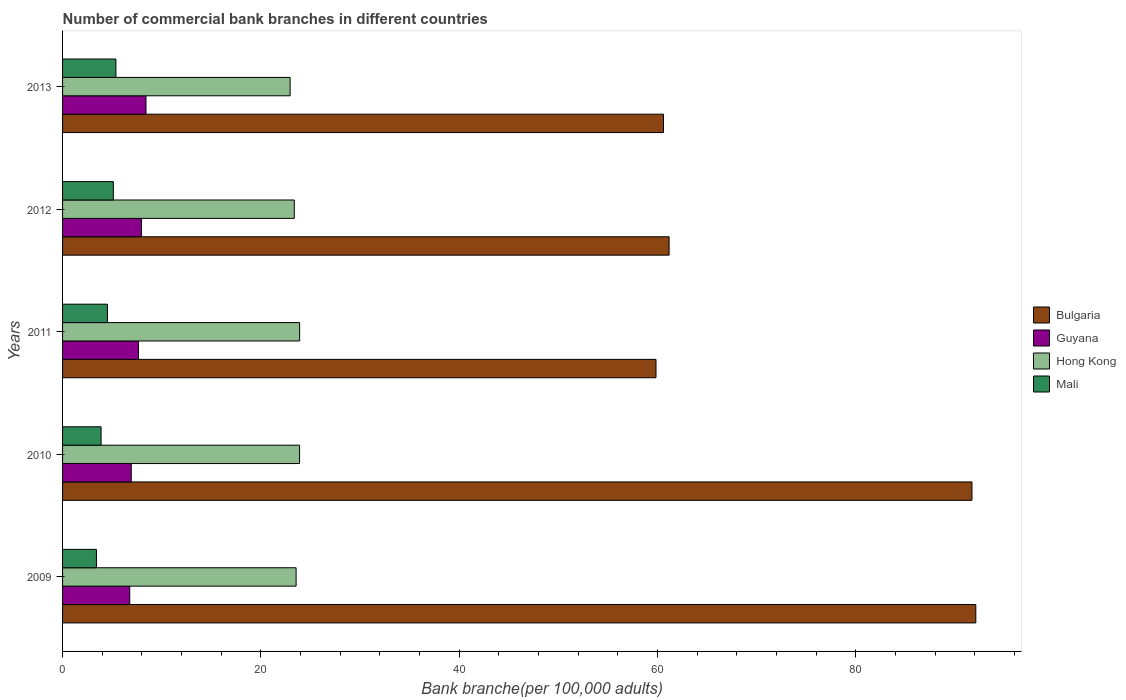How many different coloured bars are there?
Provide a succinct answer. 4. How many groups of bars are there?
Ensure brevity in your answer.  5. Are the number of bars per tick equal to the number of legend labels?
Provide a short and direct response. Yes. What is the label of the 2nd group of bars from the top?
Offer a terse response. 2012. What is the number of commercial bank branches in Hong Kong in 2009?
Give a very brief answer. 23.55. Across all years, what is the maximum number of commercial bank branches in Guyana?
Provide a short and direct response. 8.41. Across all years, what is the minimum number of commercial bank branches in Bulgaria?
Your response must be concise. 59.84. In which year was the number of commercial bank branches in Guyana maximum?
Provide a short and direct response. 2013. In which year was the number of commercial bank branches in Mali minimum?
Your answer should be very brief. 2009. What is the total number of commercial bank branches in Guyana in the graph?
Give a very brief answer. 37.73. What is the difference between the number of commercial bank branches in Mali in 2010 and that in 2013?
Keep it short and to the point. -1.5. What is the difference between the number of commercial bank branches in Hong Kong in 2010 and the number of commercial bank branches in Guyana in 2013?
Keep it short and to the point. 15.49. What is the average number of commercial bank branches in Hong Kong per year?
Your response must be concise. 23.53. In the year 2012, what is the difference between the number of commercial bank branches in Mali and number of commercial bank branches in Bulgaria?
Your response must be concise. -56.05. What is the ratio of the number of commercial bank branches in Bulgaria in 2012 to that in 2013?
Ensure brevity in your answer.  1.01. What is the difference between the highest and the second highest number of commercial bank branches in Bulgaria?
Offer a very short reply. 0.39. What is the difference between the highest and the lowest number of commercial bank branches in Guyana?
Your answer should be compact. 1.64. Is the sum of the number of commercial bank branches in Mali in 2010 and 2012 greater than the maximum number of commercial bank branches in Guyana across all years?
Your answer should be very brief. Yes. What does the 2nd bar from the top in 2013 represents?
Ensure brevity in your answer.  Hong Kong. What does the 2nd bar from the bottom in 2013 represents?
Your answer should be compact. Guyana. Is it the case that in every year, the sum of the number of commercial bank branches in Mali and number of commercial bank branches in Hong Kong is greater than the number of commercial bank branches in Guyana?
Your answer should be very brief. Yes. How many bars are there?
Your answer should be very brief. 20. Does the graph contain any zero values?
Offer a terse response. No. What is the title of the graph?
Your response must be concise. Number of commercial bank branches in different countries. Does "Jordan" appear as one of the legend labels in the graph?
Offer a terse response. No. What is the label or title of the X-axis?
Your answer should be very brief. Bank branche(per 100,0 adults). What is the label or title of the Y-axis?
Ensure brevity in your answer.  Years. What is the Bank branche(per 100,000 adults) of Bulgaria in 2009?
Give a very brief answer. 92.09. What is the Bank branche(per 100,000 adults) in Guyana in 2009?
Provide a short and direct response. 6.77. What is the Bank branche(per 100,000 adults) of Hong Kong in 2009?
Offer a very short reply. 23.55. What is the Bank branche(per 100,000 adults) in Mali in 2009?
Your answer should be very brief. 3.42. What is the Bank branche(per 100,000 adults) of Bulgaria in 2010?
Your answer should be compact. 91.71. What is the Bank branche(per 100,000 adults) of Guyana in 2010?
Keep it short and to the point. 6.93. What is the Bank branche(per 100,000 adults) in Hong Kong in 2010?
Your response must be concise. 23.9. What is the Bank branche(per 100,000 adults) in Mali in 2010?
Keep it short and to the point. 3.88. What is the Bank branche(per 100,000 adults) of Bulgaria in 2011?
Your answer should be compact. 59.84. What is the Bank branche(per 100,000 adults) in Guyana in 2011?
Your answer should be very brief. 7.66. What is the Bank branche(per 100,000 adults) of Hong Kong in 2011?
Ensure brevity in your answer.  23.91. What is the Bank branche(per 100,000 adults) in Mali in 2011?
Your answer should be very brief. 4.52. What is the Bank branche(per 100,000 adults) in Bulgaria in 2012?
Provide a succinct answer. 61.16. What is the Bank branche(per 100,000 adults) in Guyana in 2012?
Your response must be concise. 7.95. What is the Bank branche(per 100,000 adults) in Hong Kong in 2012?
Ensure brevity in your answer.  23.37. What is the Bank branche(per 100,000 adults) of Mali in 2012?
Give a very brief answer. 5.12. What is the Bank branche(per 100,000 adults) in Bulgaria in 2013?
Offer a terse response. 60.6. What is the Bank branche(per 100,000 adults) of Guyana in 2013?
Ensure brevity in your answer.  8.41. What is the Bank branche(per 100,000 adults) in Hong Kong in 2013?
Keep it short and to the point. 22.95. What is the Bank branche(per 100,000 adults) of Mali in 2013?
Ensure brevity in your answer.  5.38. Across all years, what is the maximum Bank branche(per 100,000 adults) in Bulgaria?
Give a very brief answer. 92.09. Across all years, what is the maximum Bank branche(per 100,000 adults) of Guyana?
Ensure brevity in your answer.  8.41. Across all years, what is the maximum Bank branche(per 100,000 adults) in Hong Kong?
Your response must be concise. 23.91. Across all years, what is the maximum Bank branche(per 100,000 adults) of Mali?
Your response must be concise. 5.38. Across all years, what is the minimum Bank branche(per 100,000 adults) in Bulgaria?
Your answer should be compact. 59.84. Across all years, what is the minimum Bank branche(per 100,000 adults) in Guyana?
Offer a very short reply. 6.77. Across all years, what is the minimum Bank branche(per 100,000 adults) of Hong Kong?
Offer a very short reply. 22.95. Across all years, what is the minimum Bank branche(per 100,000 adults) in Mali?
Your answer should be compact. 3.42. What is the total Bank branche(per 100,000 adults) in Bulgaria in the graph?
Give a very brief answer. 365.41. What is the total Bank branche(per 100,000 adults) in Guyana in the graph?
Your answer should be compact. 37.73. What is the total Bank branche(per 100,000 adults) of Hong Kong in the graph?
Your response must be concise. 117.67. What is the total Bank branche(per 100,000 adults) of Mali in the graph?
Provide a succinct answer. 22.32. What is the difference between the Bank branche(per 100,000 adults) of Bulgaria in 2009 and that in 2010?
Your response must be concise. 0.39. What is the difference between the Bank branche(per 100,000 adults) in Guyana in 2009 and that in 2010?
Give a very brief answer. -0.15. What is the difference between the Bank branche(per 100,000 adults) in Hong Kong in 2009 and that in 2010?
Give a very brief answer. -0.35. What is the difference between the Bank branche(per 100,000 adults) of Mali in 2009 and that in 2010?
Offer a terse response. -0.47. What is the difference between the Bank branche(per 100,000 adults) of Bulgaria in 2009 and that in 2011?
Give a very brief answer. 32.25. What is the difference between the Bank branche(per 100,000 adults) in Guyana in 2009 and that in 2011?
Your response must be concise. -0.88. What is the difference between the Bank branche(per 100,000 adults) in Hong Kong in 2009 and that in 2011?
Provide a short and direct response. -0.36. What is the difference between the Bank branche(per 100,000 adults) of Mali in 2009 and that in 2011?
Your answer should be compact. -1.11. What is the difference between the Bank branche(per 100,000 adults) in Bulgaria in 2009 and that in 2012?
Your answer should be compact. 30.93. What is the difference between the Bank branche(per 100,000 adults) of Guyana in 2009 and that in 2012?
Offer a terse response. -1.18. What is the difference between the Bank branche(per 100,000 adults) in Hong Kong in 2009 and that in 2012?
Keep it short and to the point. 0.18. What is the difference between the Bank branche(per 100,000 adults) in Mali in 2009 and that in 2012?
Make the answer very short. -1.7. What is the difference between the Bank branche(per 100,000 adults) in Bulgaria in 2009 and that in 2013?
Provide a short and direct response. 31.5. What is the difference between the Bank branche(per 100,000 adults) of Guyana in 2009 and that in 2013?
Provide a succinct answer. -1.64. What is the difference between the Bank branche(per 100,000 adults) in Hong Kong in 2009 and that in 2013?
Your response must be concise. 0.6. What is the difference between the Bank branche(per 100,000 adults) of Mali in 2009 and that in 2013?
Offer a terse response. -1.96. What is the difference between the Bank branche(per 100,000 adults) of Bulgaria in 2010 and that in 2011?
Provide a succinct answer. 31.86. What is the difference between the Bank branche(per 100,000 adults) of Guyana in 2010 and that in 2011?
Your response must be concise. -0.73. What is the difference between the Bank branche(per 100,000 adults) of Hong Kong in 2010 and that in 2011?
Make the answer very short. -0.01. What is the difference between the Bank branche(per 100,000 adults) of Mali in 2010 and that in 2011?
Keep it short and to the point. -0.64. What is the difference between the Bank branche(per 100,000 adults) in Bulgaria in 2010 and that in 2012?
Keep it short and to the point. 30.54. What is the difference between the Bank branche(per 100,000 adults) of Guyana in 2010 and that in 2012?
Your response must be concise. -1.03. What is the difference between the Bank branche(per 100,000 adults) of Hong Kong in 2010 and that in 2012?
Your answer should be compact. 0.53. What is the difference between the Bank branche(per 100,000 adults) of Mali in 2010 and that in 2012?
Ensure brevity in your answer.  -1.24. What is the difference between the Bank branche(per 100,000 adults) in Bulgaria in 2010 and that in 2013?
Ensure brevity in your answer.  31.11. What is the difference between the Bank branche(per 100,000 adults) of Guyana in 2010 and that in 2013?
Your answer should be compact. -1.49. What is the difference between the Bank branche(per 100,000 adults) in Hong Kong in 2010 and that in 2013?
Ensure brevity in your answer.  0.95. What is the difference between the Bank branche(per 100,000 adults) of Mali in 2010 and that in 2013?
Offer a terse response. -1.5. What is the difference between the Bank branche(per 100,000 adults) in Bulgaria in 2011 and that in 2012?
Provide a short and direct response. -1.32. What is the difference between the Bank branche(per 100,000 adults) in Guyana in 2011 and that in 2012?
Provide a short and direct response. -0.3. What is the difference between the Bank branche(per 100,000 adults) of Hong Kong in 2011 and that in 2012?
Provide a short and direct response. 0.54. What is the difference between the Bank branche(per 100,000 adults) of Mali in 2011 and that in 2012?
Make the answer very short. -0.59. What is the difference between the Bank branche(per 100,000 adults) in Bulgaria in 2011 and that in 2013?
Keep it short and to the point. -0.75. What is the difference between the Bank branche(per 100,000 adults) in Guyana in 2011 and that in 2013?
Your answer should be compact. -0.75. What is the difference between the Bank branche(per 100,000 adults) in Hong Kong in 2011 and that in 2013?
Your answer should be very brief. 0.96. What is the difference between the Bank branche(per 100,000 adults) in Mali in 2011 and that in 2013?
Provide a succinct answer. -0.85. What is the difference between the Bank branche(per 100,000 adults) in Bulgaria in 2012 and that in 2013?
Your answer should be compact. 0.57. What is the difference between the Bank branche(per 100,000 adults) of Guyana in 2012 and that in 2013?
Your answer should be compact. -0.46. What is the difference between the Bank branche(per 100,000 adults) of Hong Kong in 2012 and that in 2013?
Provide a succinct answer. 0.42. What is the difference between the Bank branche(per 100,000 adults) of Mali in 2012 and that in 2013?
Give a very brief answer. -0.26. What is the difference between the Bank branche(per 100,000 adults) of Bulgaria in 2009 and the Bank branche(per 100,000 adults) of Guyana in 2010?
Your answer should be compact. 85.17. What is the difference between the Bank branche(per 100,000 adults) of Bulgaria in 2009 and the Bank branche(per 100,000 adults) of Hong Kong in 2010?
Keep it short and to the point. 68.19. What is the difference between the Bank branche(per 100,000 adults) in Bulgaria in 2009 and the Bank branche(per 100,000 adults) in Mali in 2010?
Offer a very short reply. 88.21. What is the difference between the Bank branche(per 100,000 adults) of Guyana in 2009 and the Bank branche(per 100,000 adults) of Hong Kong in 2010?
Keep it short and to the point. -17.13. What is the difference between the Bank branche(per 100,000 adults) in Guyana in 2009 and the Bank branche(per 100,000 adults) in Mali in 2010?
Your answer should be very brief. 2.89. What is the difference between the Bank branche(per 100,000 adults) of Hong Kong in 2009 and the Bank branche(per 100,000 adults) of Mali in 2010?
Give a very brief answer. 19.67. What is the difference between the Bank branche(per 100,000 adults) in Bulgaria in 2009 and the Bank branche(per 100,000 adults) in Guyana in 2011?
Offer a terse response. 84.44. What is the difference between the Bank branche(per 100,000 adults) in Bulgaria in 2009 and the Bank branche(per 100,000 adults) in Hong Kong in 2011?
Ensure brevity in your answer.  68.19. What is the difference between the Bank branche(per 100,000 adults) in Bulgaria in 2009 and the Bank branche(per 100,000 adults) in Mali in 2011?
Your answer should be compact. 87.57. What is the difference between the Bank branche(per 100,000 adults) of Guyana in 2009 and the Bank branche(per 100,000 adults) of Hong Kong in 2011?
Give a very brief answer. -17.13. What is the difference between the Bank branche(per 100,000 adults) of Guyana in 2009 and the Bank branche(per 100,000 adults) of Mali in 2011?
Make the answer very short. 2.25. What is the difference between the Bank branche(per 100,000 adults) in Hong Kong in 2009 and the Bank branche(per 100,000 adults) in Mali in 2011?
Your answer should be compact. 19.03. What is the difference between the Bank branche(per 100,000 adults) of Bulgaria in 2009 and the Bank branche(per 100,000 adults) of Guyana in 2012?
Your response must be concise. 84.14. What is the difference between the Bank branche(per 100,000 adults) of Bulgaria in 2009 and the Bank branche(per 100,000 adults) of Hong Kong in 2012?
Your answer should be compact. 68.73. What is the difference between the Bank branche(per 100,000 adults) of Bulgaria in 2009 and the Bank branche(per 100,000 adults) of Mali in 2012?
Provide a short and direct response. 86.97. What is the difference between the Bank branche(per 100,000 adults) of Guyana in 2009 and the Bank branche(per 100,000 adults) of Hong Kong in 2012?
Offer a very short reply. -16.59. What is the difference between the Bank branche(per 100,000 adults) of Guyana in 2009 and the Bank branche(per 100,000 adults) of Mali in 2012?
Provide a short and direct response. 1.66. What is the difference between the Bank branche(per 100,000 adults) of Hong Kong in 2009 and the Bank branche(per 100,000 adults) of Mali in 2012?
Make the answer very short. 18.43. What is the difference between the Bank branche(per 100,000 adults) in Bulgaria in 2009 and the Bank branche(per 100,000 adults) in Guyana in 2013?
Offer a very short reply. 83.68. What is the difference between the Bank branche(per 100,000 adults) of Bulgaria in 2009 and the Bank branche(per 100,000 adults) of Hong Kong in 2013?
Ensure brevity in your answer.  69.15. What is the difference between the Bank branche(per 100,000 adults) of Bulgaria in 2009 and the Bank branche(per 100,000 adults) of Mali in 2013?
Ensure brevity in your answer.  86.71. What is the difference between the Bank branche(per 100,000 adults) in Guyana in 2009 and the Bank branche(per 100,000 adults) in Hong Kong in 2013?
Your answer should be very brief. -16.17. What is the difference between the Bank branche(per 100,000 adults) of Guyana in 2009 and the Bank branche(per 100,000 adults) of Mali in 2013?
Make the answer very short. 1.4. What is the difference between the Bank branche(per 100,000 adults) of Hong Kong in 2009 and the Bank branche(per 100,000 adults) of Mali in 2013?
Offer a very short reply. 18.17. What is the difference between the Bank branche(per 100,000 adults) in Bulgaria in 2010 and the Bank branche(per 100,000 adults) in Guyana in 2011?
Offer a terse response. 84.05. What is the difference between the Bank branche(per 100,000 adults) in Bulgaria in 2010 and the Bank branche(per 100,000 adults) in Hong Kong in 2011?
Provide a succinct answer. 67.8. What is the difference between the Bank branche(per 100,000 adults) in Bulgaria in 2010 and the Bank branche(per 100,000 adults) in Mali in 2011?
Your answer should be compact. 87.18. What is the difference between the Bank branche(per 100,000 adults) of Guyana in 2010 and the Bank branche(per 100,000 adults) of Hong Kong in 2011?
Provide a short and direct response. -16.98. What is the difference between the Bank branche(per 100,000 adults) of Guyana in 2010 and the Bank branche(per 100,000 adults) of Mali in 2011?
Offer a terse response. 2.4. What is the difference between the Bank branche(per 100,000 adults) of Hong Kong in 2010 and the Bank branche(per 100,000 adults) of Mali in 2011?
Ensure brevity in your answer.  19.38. What is the difference between the Bank branche(per 100,000 adults) of Bulgaria in 2010 and the Bank branche(per 100,000 adults) of Guyana in 2012?
Offer a very short reply. 83.75. What is the difference between the Bank branche(per 100,000 adults) in Bulgaria in 2010 and the Bank branche(per 100,000 adults) in Hong Kong in 2012?
Ensure brevity in your answer.  68.34. What is the difference between the Bank branche(per 100,000 adults) in Bulgaria in 2010 and the Bank branche(per 100,000 adults) in Mali in 2012?
Offer a terse response. 86.59. What is the difference between the Bank branche(per 100,000 adults) in Guyana in 2010 and the Bank branche(per 100,000 adults) in Hong Kong in 2012?
Your answer should be compact. -16.44. What is the difference between the Bank branche(per 100,000 adults) of Guyana in 2010 and the Bank branche(per 100,000 adults) of Mali in 2012?
Your answer should be very brief. 1.81. What is the difference between the Bank branche(per 100,000 adults) in Hong Kong in 2010 and the Bank branche(per 100,000 adults) in Mali in 2012?
Provide a succinct answer. 18.78. What is the difference between the Bank branche(per 100,000 adults) of Bulgaria in 2010 and the Bank branche(per 100,000 adults) of Guyana in 2013?
Provide a short and direct response. 83.29. What is the difference between the Bank branche(per 100,000 adults) of Bulgaria in 2010 and the Bank branche(per 100,000 adults) of Hong Kong in 2013?
Provide a succinct answer. 68.76. What is the difference between the Bank branche(per 100,000 adults) in Bulgaria in 2010 and the Bank branche(per 100,000 adults) in Mali in 2013?
Your answer should be compact. 86.33. What is the difference between the Bank branche(per 100,000 adults) of Guyana in 2010 and the Bank branche(per 100,000 adults) of Hong Kong in 2013?
Keep it short and to the point. -16.02. What is the difference between the Bank branche(per 100,000 adults) of Guyana in 2010 and the Bank branche(per 100,000 adults) of Mali in 2013?
Provide a succinct answer. 1.55. What is the difference between the Bank branche(per 100,000 adults) in Hong Kong in 2010 and the Bank branche(per 100,000 adults) in Mali in 2013?
Your response must be concise. 18.52. What is the difference between the Bank branche(per 100,000 adults) in Bulgaria in 2011 and the Bank branche(per 100,000 adults) in Guyana in 2012?
Provide a short and direct response. 51.89. What is the difference between the Bank branche(per 100,000 adults) in Bulgaria in 2011 and the Bank branche(per 100,000 adults) in Hong Kong in 2012?
Ensure brevity in your answer.  36.48. What is the difference between the Bank branche(per 100,000 adults) of Bulgaria in 2011 and the Bank branche(per 100,000 adults) of Mali in 2012?
Give a very brief answer. 54.72. What is the difference between the Bank branche(per 100,000 adults) of Guyana in 2011 and the Bank branche(per 100,000 adults) of Hong Kong in 2012?
Provide a short and direct response. -15.71. What is the difference between the Bank branche(per 100,000 adults) in Guyana in 2011 and the Bank branche(per 100,000 adults) in Mali in 2012?
Offer a terse response. 2.54. What is the difference between the Bank branche(per 100,000 adults) in Hong Kong in 2011 and the Bank branche(per 100,000 adults) in Mali in 2012?
Offer a terse response. 18.79. What is the difference between the Bank branche(per 100,000 adults) in Bulgaria in 2011 and the Bank branche(per 100,000 adults) in Guyana in 2013?
Provide a succinct answer. 51.43. What is the difference between the Bank branche(per 100,000 adults) in Bulgaria in 2011 and the Bank branche(per 100,000 adults) in Hong Kong in 2013?
Provide a succinct answer. 36.9. What is the difference between the Bank branche(per 100,000 adults) of Bulgaria in 2011 and the Bank branche(per 100,000 adults) of Mali in 2013?
Your answer should be very brief. 54.46. What is the difference between the Bank branche(per 100,000 adults) of Guyana in 2011 and the Bank branche(per 100,000 adults) of Hong Kong in 2013?
Keep it short and to the point. -15.29. What is the difference between the Bank branche(per 100,000 adults) in Guyana in 2011 and the Bank branche(per 100,000 adults) in Mali in 2013?
Keep it short and to the point. 2.28. What is the difference between the Bank branche(per 100,000 adults) of Hong Kong in 2011 and the Bank branche(per 100,000 adults) of Mali in 2013?
Your answer should be compact. 18.53. What is the difference between the Bank branche(per 100,000 adults) in Bulgaria in 2012 and the Bank branche(per 100,000 adults) in Guyana in 2013?
Keep it short and to the point. 52.75. What is the difference between the Bank branche(per 100,000 adults) of Bulgaria in 2012 and the Bank branche(per 100,000 adults) of Hong Kong in 2013?
Provide a short and direct response. 38.22. What is the difference between the Bank branche(per 100,000 adults) of Bulgaria in 2012 and the Bank branche(per 100,000 adults) of Mali in 2013?
Provide a short and direct response. 55.79. What is the difference between the Bank branche(per 100,000 adults) of Guyana in 2012 and the Bank branche(per 100,000 adults) of Hong Kong in 2013?
Provide a succinct answer. -14.99. What is the difference between the Bank branche(per 100,000 adults) of Guyana in 2012 and the Bank branche(per 100,000 adults) of Mali in 2013?
Your answer should be compact. 2.57. What is the difference between the Bank branche(per 100,000 adults) of Hong Kong in 2012 and the Bank branche(per 100,000 adults) of Mali in 2013?
Offer a terse response. 17.99. What is the average Bank branche(per 100,000 adults) in Bulgaria per year?
Ensure brevity in your answer.  73.08. What is the average Bank branche(per 100,000 adults) in Guyana per year?
Provide a succinct answer. 7.55. What is the average Bank branche(per 100,000 adults) of Hong Kong per year?
Provide a short and direct response. 23.53. What is the average Bank branche(per 100,000 adults) of Mali per year?
Provide a succinct answer. 4.46. In the year 2009, what is the difference between the Bank branche(per 100,000 adults) of Bulgaria and Bank branche(per 100,000 adults) of Guyana?
Give a very brief answer. 85.32. In the year 2009, what is the difference between the Bank branche(per 100,000 adults) of Bulgaria and Bank branche(per 100,000 adults) of Hong Kong?
Your answer should be compact. 68.54. In the year 2009, what is the difference between the Bank branche(per 100,000 adults) in Bulgaria and Bank branche(per 100,000 adults) in Mali?
Offer a very short reply. 88.68. In the year 2009, what is the difference between the Bank branche(per 100,000 adults) in Guyana and Bank branche(per 100,000 adults) in Hong Kong?
Provide a succinct answer. -16.78. In the year 2009, what is the difference between the Bank branche(per 100,000 adults) in Guyana and Bank branche(per 100,000 adults) in Mali?
Give a very brief answer. 3.36. In the year 2009, what is the difference between the Bank branche(per 100,000 adults) in Hong Kong and Bank branche(per 100,000 adults) in Mali?
Ensure brevity in your answer.  20.14. In the year 2010, what is the difference between the Bank branche(per 100,000 adults) of Bulgaria and Bank branche(per 100,000 adults) of Guyana?
Your answer should be very brief. 84.78. In the year 2010, what is the difference between the Bank branche(per 100,000 adults) of Bulgaria and Bank branche(per 100,000 adults) of Hong Kong?
Make the answer very short. 67.8. In the year 2010, what is the difference between the Bank branche(per 100,000 adults) in Bulgaria and Bank branche(per 100,000 adults) in Mali?
Provide a succinct answer. 87.82. In the year 2010, what is the difference between the Bank branche(per 100,000 adults) in Guyana and Bank branche(per 100,000 adults) in Hong Kong?
Your response must be concise. -16.97. In the year 2010, what is the difference between the Bank branche(per 100,000 adults) of Guyana and Bank branche(per 100,000 adults) of Mali?
Keep it short and to the point. 3.04. In the year 2010, what is the difference between the Bank branche(per 100,000 adults) in Hong Kong and Bank branche(per 100,000 adults) in Mali?
Your response must be concise. 20.02. In the year 2011, what is the difference between the Bank branche(per 100,000 adults) in Bulgaria and Bank branche(per 100,000 adults) in Guyana?
Make the answer very short. 52.18. In the year 2011, what is the difference between the Bank branche(per 100,000 adults) in Bulgaria and Bank branche(per 100,000 adults) in Hong Kong?
Keep it short and to the point. 35.94. In the year 2011, what is the difference between the Bank branche(per 100,000 adults) in Bulgaria and Bank branche(per 100,000 adults) in Mali?
Keep it short and to the point. 55.32. In the year 2011, what is the difference between the Bank branche(per 100,000 adults) in Guyana and Bank branche(per 100,000 adults) in Hong Kong?
Provide a short and direct response. -16.25. In the year 2011, what is the difference between the Bank branche(per 100,000 adults) of Guyana and Bank branche(per 100,000 adults) of Mali?
Offer a very short reply. 3.13. In the year 2011, what is the difference between the Bank branche(per 100,000 adults) in Hong Kong and Bank branche(per 100,000 adults) in Mali?
Your answer should be very brief. 19.38. In the year 2012, what is the difference between the Bank branche(per 100,000 adults) of Bulgaria and Bank branche(per 100,000 adults) of Guyana?
Make the answer very short. 53.21. In the year 2012, what is the difference between the Bank branche(per 100,000 adults) in Bulgaria and Bank branche(per 100,000 adults) in Hong Kong?
Ensure brevity in your answer.  37.8. In the year 2012, what is the difference between the Bank branche(per 100,000 adults) in Bulgaria and Bank branche(per 100,000 adults) in Mali?
Provide a short and direct response. 56.05. In the year 2012, what is the difference between the Bank branche(per 100,000 adults) in Guyana and Bank branche(per 100,000 adults) in Hong Kong?
Ensure brevity in your answer.  -15.41. In the year 2012, what is the difference between the Bank branche(per 100,000 adults) in Guyana and Bank branche(per 100,000 adults) in Mali?
Keep it short and to the point. 2.83. In the year 2012, what is the difference between the Bank branche(per 100,000 adults) in Hong Kong and Bank branche(per 100,000 adults) in Mali?
Provide a short and direct response. 18.25. In the year 2013, what is the difference between the Bank branche(per 100,000 adults) in Bulgaria and Bank branche(per 100,000 adults) in Guyana?
Give a very brief answer. 52.18. In the year 2013, what is the difference between the Bank branche(per 100,000 adults) in Bulgaria and Bank branche(per 100,000 adults) in Hong Kong?
Keep it short and to the point. 37.65. In the year 2013, what is the difference between the Bank branche(per 100,000 adults) of Bulgaria and Bank branche(per 100,000 adults) of Mali?
Offer a terse response. 55.22. In the year 2013, what is the difference between the Bank branche(per 100,000 adults) of Guyana and Bank branche(per 100,000 adults) of Hong Kong?
Your response must be concise. -14.53. In the year 2013, what is the difference between the Bank branche(per 100,000 adults) of Guyana and Bank branche(per 100,000 adults) of Mali?
Offer a very short reply. 3.03. In the year 2013, what is the difference between the Bank branche(per 100,000 adults) in Hong Kong and Bank branche(per 100,000 adults) in Mali?
Give a very brief answer. 17.57. What is the ratio of the Bank branche(per 100,000 adults) of Bulgaria in 2009 to that in 2010?
Give a very brief answer. 1. What is the ratio of the Bank branche(per 100,000 adults) in Guyana in 2009 to that in 2010?
Make the answer very short. 0.98. What is the ratio of the Bank branche(per 100,000 adults) of Hong Kong in 2009 to that in 2010?
Ensure brevity in your answer.  0.99. What is the ratio of the Bank branche(per 100,000 adults) of Mali in 2009 to that in 2010?
Provide a succinct answer. 0.88. What is the ratio of the Bank branche(per 100,000 adults) of Bulgaria in 2009 to that in 2011?
Provide a succinct answer. 1.54. What is the ratio of the Bank branche(per 100,000 adults) of Guyana in 2009 to that in 2011?
Make the answer very short. 0.88. What is the ratio of the Bank branche(per 100,000 adults) in Hong Kong in 2009 to that in 2011?
Keep it short and to the point. 0.99. What is the ratio of the Bank branche(per 100,000 adults) of Mali in 2009 to that in 2011?
Your answer should be very brief. 0.75. What is the ratio of the Bank branche(per 100,000 adults) of Bulgaria in 2009 to that in 2012?
Provide a succinct answer. 1.51. What is the ratio of the Bank branche(per 100,000 adults) in Guyana in 2009 to that in 2012?
Provide a short and direct response. 0.85. What is the ratio of the Bank branche(per 100,000 adults) in Hong Kong in 2009 to that in 2012?
Offer a terse response. 1.01. What is the ratio of the Bank branche(per 100,000 adults) in Mali in 2009 to that in 2012?
Your answer should be compact. 0.67. What is the ratio of the Bank branche(per 100,000 adults) of Bulgaria in 2009 to that in 2013?
Your answer should be very brief. 1.52. What is the ratio of the Bank branche(per 100,000 adults) of Guyana in 2009 to that in 2013?
Ensure brevity in your answer.  0.81. What is the ratio of the Bank branche(per 100,000 adults) of Hong Kong in 2009 to that in 2013?
Provide a short and direct response. 1.03. What is the ratio of the Bank branche(per 100,000 adults) of Mali in 2009 to that in 2013?
Offer a terse response. 0.63. What is the ratio of the Bank branche(per 100,000 adults) of Bulgaria in 2010 to that in 2011?
Keep it short and to the point. 1.53. What is the ratio of the Bank branche(per 100,000 adults) in Guyana in 2010 to that in 2011?
Make the answer very short. 0.9. What is the ratio of the Bank branche(per 100,000 adults) in Mali in 2010 to that in 2011?
Your answer should be compact. 0.86. What is the ratio of the Bank branche(per 100,000 adults) in Bulgaria in 2010 to that in 2012?
Your answer should be compact. 1.5. What is the ratio of the Bank branche(per 100,000 adults) in Guyana in 2010 to that in 2012?
Provide a short and direct response. 0.87. What is the ratio of the Bank branche(per 100,000 adults) of Hong Kong in 2010 to that in 2012?
Make the answer very short. 1.02. What is the ratio of the Bank branche(per 100,000 adults) of Mali in 2010 to that in 2012?
Keep it short and to the point. 0.76. What is the ratio of the Bank branche(per 100,000 adults) of Bulgaria in 2010 to that in 2013?
Offer a very short reply. 1.51. What is the ratio of the Bank branche(per 100,000 adults) of Guyana in 2010 to that in 2013?
Offer a terse response. 0.82. What is the ratio of the Bank branche(per 100,000 adults) of Hong Kong in 2010 to that in 2013?
Offer a very short reply. 1.04. What is the ratio of the Bank branche(per 100,000 adults) in Mali in 2010 to that in 2013?
Offer a terse response. 0.72. What is the ratio of the Bank branche(per 100,000 adults) of Bulgaria in 2011 to that in 2012?
Give a very brief answer. 0.98. What is the ratio of the Bank branche(per 100,000 adults) of Guyana in 2011 to that in 2012?
Make the answer very short. 0.96. What is the ratio of the Bank branche(per 100,000 adults) in Hong Kong in 2011 to that in 2012?
Give a very brief answer. 1.02. What is the ratio of the Bank branche(per 100,000 adults) in Mali in 2011 to that in 2012?
Give a very brief answer. 0.88. What is the ratio of the Bank branche(per 100,000 adults) of Bulgaria in 2011 to that in 2013?
Offer a terse response. 0.99. What is the ratio of the Bank branche(per 100,000 adults) of Guyana in 2011 to that in 2013?
Your response must be concise. 0.91. What is the ratio of the Bank branche(per 100,000 adults) in Hong Kong in 2011 to that in 2013?
Keep it short and to the point. 1.04. What is the ratio of the Bank branche(per 100,000 adults) of Mali in 2011 to that in 2013?
Your answer should be very brief. 0.84. What is the ratio of the Bank branche(per 100,000 adults) in Bulgaria in 2012 to that in 2013?
Your answer should be compact. 1.01. What is the ratio of the Bank branche(per 100,000 adults) in Guyana in 2012 to that in 2013?
Offer a very short reply. 0.95. What is the ratio of the Bank branche(per 100,000 adults) in Hong Kong in 2012 to that in 2013?
Your response must be concise. 1.02. What is the ratio of the Bank branche(per 100,000 adults) of Mali in 2012 to that in 2013?
Make the answer very short. 0.95. What is the difference between the highest and the second highest Bank branche(per 100,000 adults) in Bulgaria?
Provide a succinct answer. 0.39. What is the difference between the highest and the second highest Bank branche(per 100,000 adults) in Guyana?
Keep it short and to the point. 0.46. What is the difference between the highest and the second highest Bank branche(per 100,000 adults) in Hong Kong?
Your answer should be very brief. 0.01. What is the difference between the highest and the second highest Bank branche(per 100,000 adults) of Mali?
Give a very brief answer. 0.26. What is the difference between the highest and the lowest Bank branche(per 100,000 adults) of Bulgaria?
Your answer should be very brief. 32.25. What is the difference between the highest and the lowest Bank branche(per 100,000 adults) of Guyana?
Keep it short and to the point. 1.64. What is the difference between the highest and the lowest Bank branche(per 100,000 adults) in Hong Kong?
Your response must be concise. 0.96. What is the difference between the highest and the lowest Bank branche(per 100,000 adults) of Mali?
Ensure brevity in your answer.  1.96. 